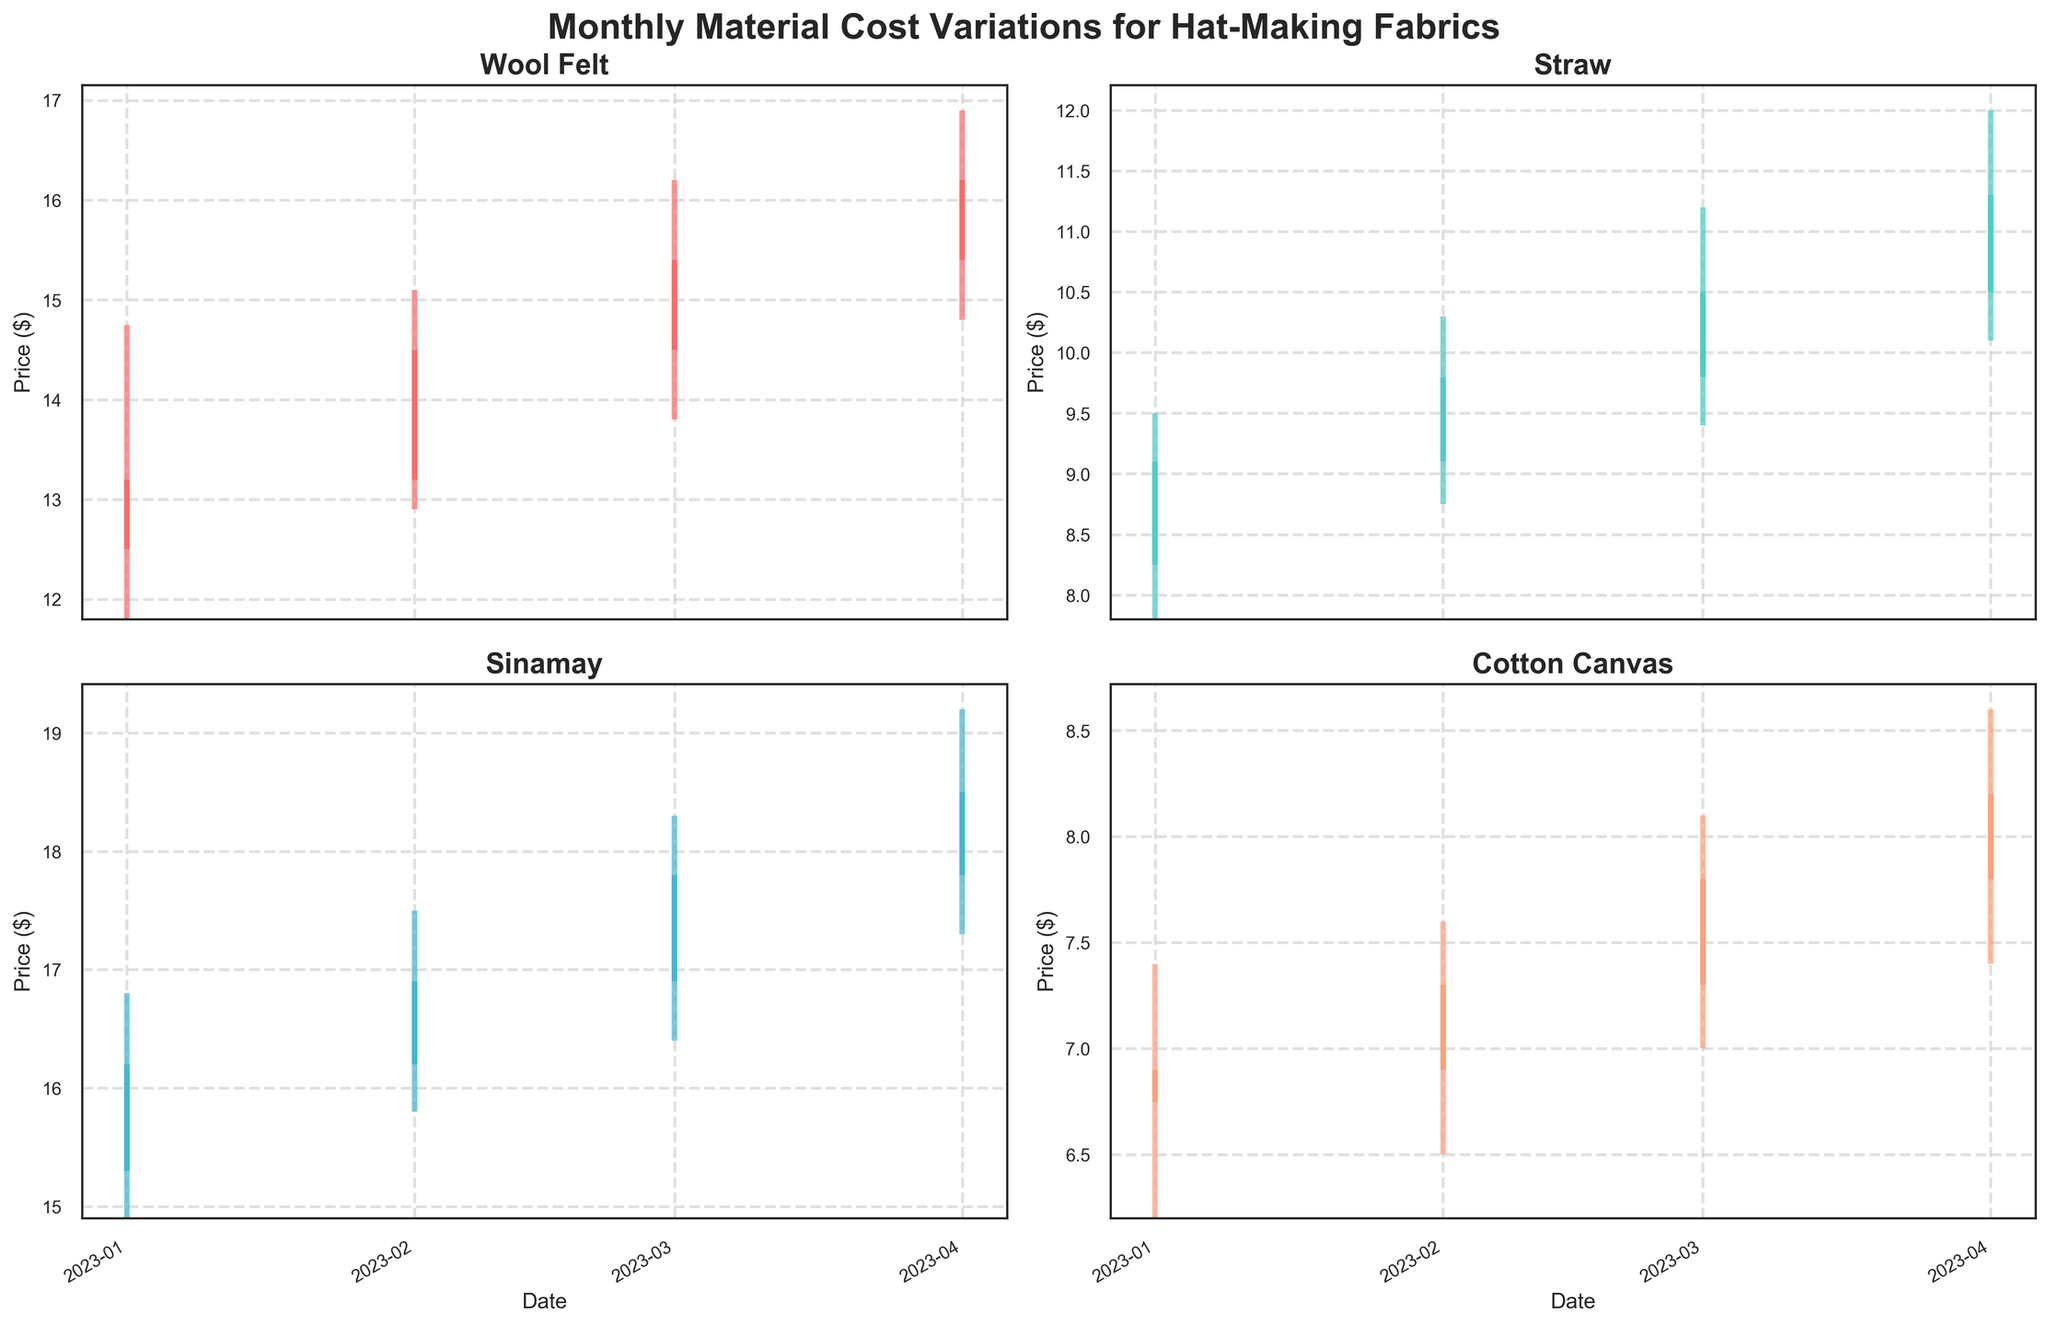What's the title of the figure? The title of the figure is found at the top of the chart and usually provides a summary of what the data represents. In this case, it succinctly describes that the figure shows monthly material cost variations for hat-making fabrics.
Answer: Monthly Material Cost Variations for Hat-Making Fabrics How many materials are displayed in the figure? The figure presents four different types of materials. This can be seen by counting the number of subplots in the figure, each with its own title, representing a unique material.
Answer: Four For which month did Wool Felt have the highest closing price? To find this, look at the subplot for Wool Felt and identify the month where the closing price (rightmost part of each candlestick) reaches its highest value. The highest closing price for Wool Felt occurs in April 2023.
Answer: April 2023 Which material had the greatest range between its highest and lowest price in January 2023? To determine this, compare the height difference between the highest and lowest points in January for each material. The material with the largest range is Sinamay, with a high of 16.80 and a low of 14.90 resulting in a range of 1.90.
Answer: Sinamay What was the trend in the opening prices of Cotton Canvas from January to April 2023? Examine the starting points (bottom of each bar) of Cotton Canvas over the months. The opening prices show an increasing trend, with values starting at 6.75 in January, rising to 6.90 in February, 7.30 in March, and reaching 7.80 in April.
Answer: Increasing trend Compare the closing prices of Straw and Sinamay in February 2023. Which material had the higher closing price? For February 2023, look at the position of the closing price (right side of the candlestick) in each subplot for Straw and Sinamay. Sinamay had a higher closing price (16.90) compared to Straw (9.80).
Answer: Sinamay Which month had the lowest price for Cotton Canvas? Identify the lowest point on each candlestick for the months displayed in the Cotton Canvas subplot. January 2023 has the lowest price with a low of 6.20.
Answer: January 2023 Which material showed a consistent increase in closing prices from January to April 2023? To answer this, observe the right ends of the candlesticks over these months for each material. Wool Felt shows a consistent increase in closing prices from 13.20 in January to 16.20 in April.
Answer: Wool Felt What was the difference in the closing prices of Wool Felt between March and April 2023? Look at the closing prices for Wool Felt in March (15.40) and April (16.20) and then subtract the March price from the April price. The difference is 16.20 - 15.40 = 0.80.
Answer: 0.80 